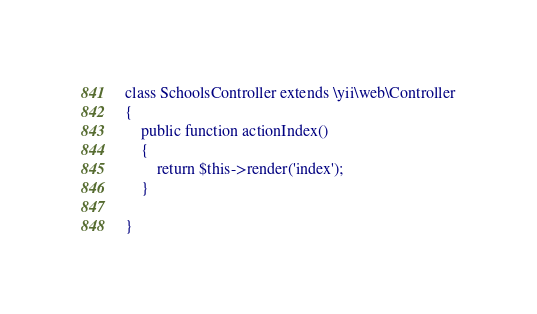Convert code to text. <code><loc_0><loc_0><loc_500><loc_500><_PHP_>class SchoolsController extends \yii\web\Controller
{
    public function actionIndex()
    {
        return $this->render('index');
    }

}
</code> 